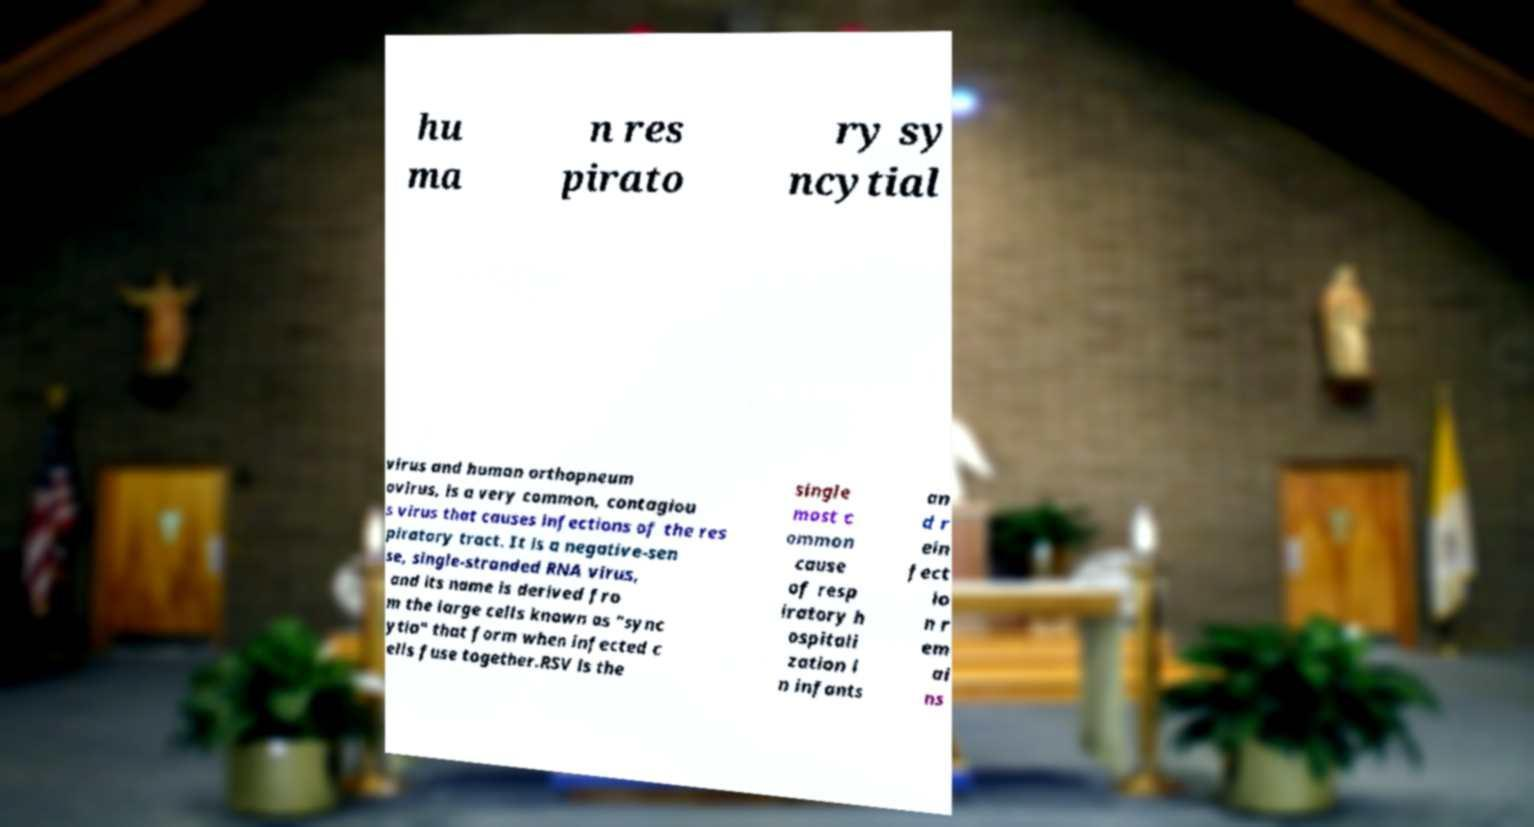There's text embedded in this image that I need extracted. Can you transcribe it verbatim? hu ma n res pirato ry sy ncytial virus and human orthopneum ovirus, is a very common, contagiou s virus that causes infections of the res piratory tract. It is a negative-sen se, single-stranded RNA virus, and its name is derived fro m the large cells known as "sync ytia" that form when infected c ells fuse together.RSV is the single most c ommon cause of resp iratory h ospitali zation i n infants an d r ein fect io n r em ai ns 